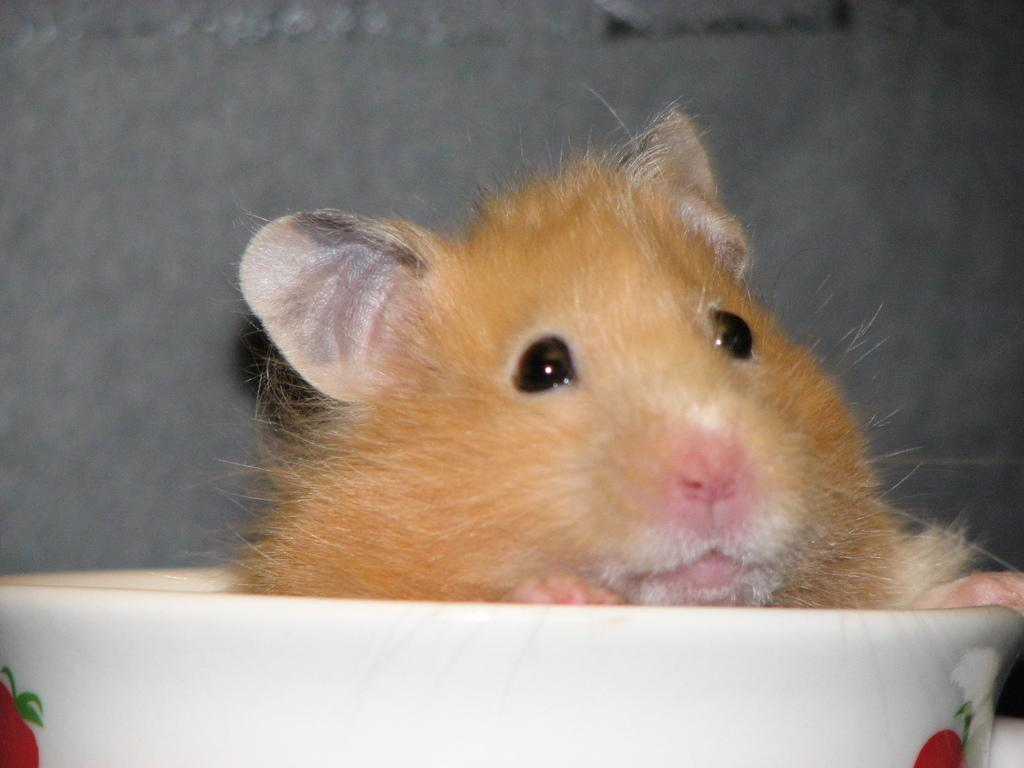What is in the bowl in the foreground of the image? There is an animal in the bowl in the foreground. Can you describe the appearance of the bowl? The bowl is white with a red design. What can be seen in the background of the image? There is a wall in the background of the image. What type of hat is the animal wearing in the image? There is no hat present in the image; the animal is in a bowl. 